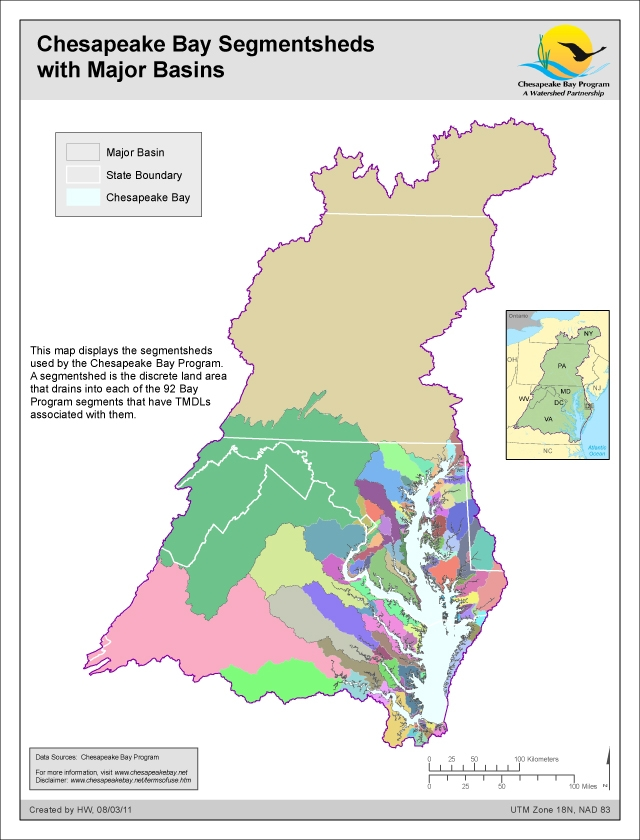How does the color coding of the segmentsheds help in understanding the distribution of watersheds in the Chesapeake Bay area? The color coding of the segmentsheds in the map provides a clear visual differentiation of the distinct watersheds within the Chesapeake Bay area. Each color represents a specific segmentshed, making it easier to identify and study the spatial distribution and extent of each watershed. This visual tool is crucial for environmental management, as it helps stakeholders quickly grasp the geographical spread and interconnections of the watersheds. Such understanding is fundamental for planning, resource allocation, and implementing targeted conservation efforts across the Bay area. 